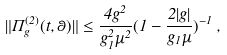<formula> <loc_0><loc_0><loc_500><loc_500>\| \Pi _ { g } ^ { ( 2 ) } ( t , \theta ) \| \leq \frac { 4 g ^ { 2 } } { g _ { 1 } ^ { 2 } \mu ^ { 2 } } ( 1 - \frac { 2 | g | } { g _ { 1 } \mu } ) ^ { - 1 } \, ,</formula> 